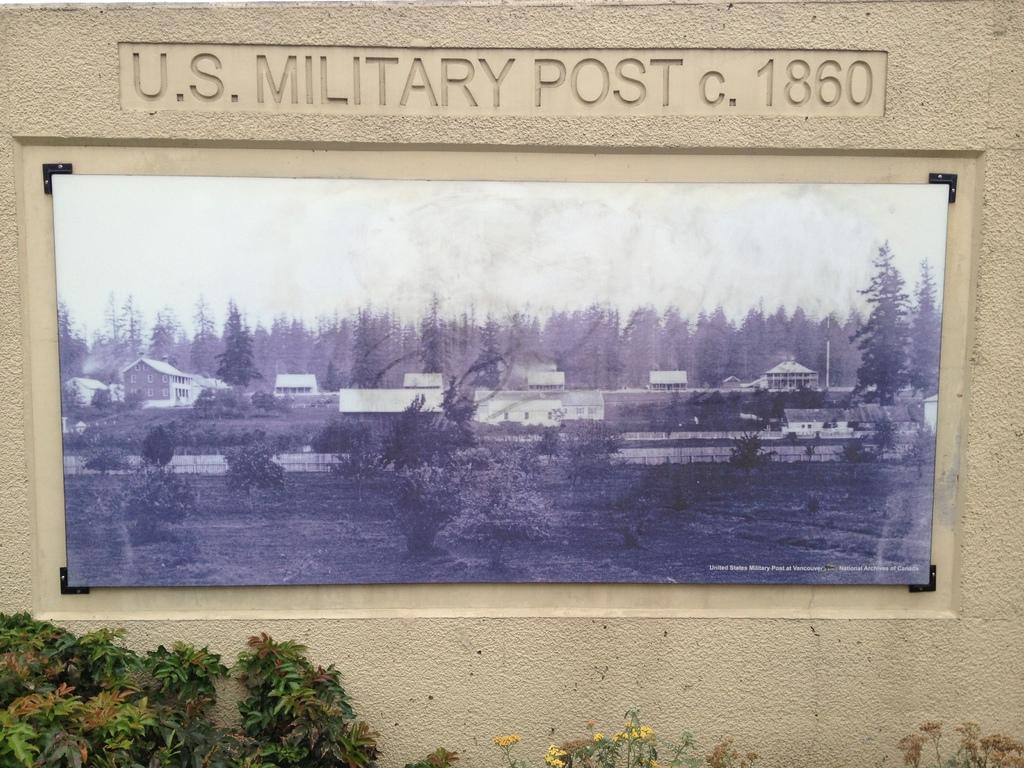What type of image is displayed in the picture? There is a black and white photography in the image. Where is the photography located? The photography is on a wall. What else can be seen below the photography? There are plants below the photography. What type of yarn is used to create the coat in the image? There is no coat or yarn present in the image; it features a black and white photography and plants. 